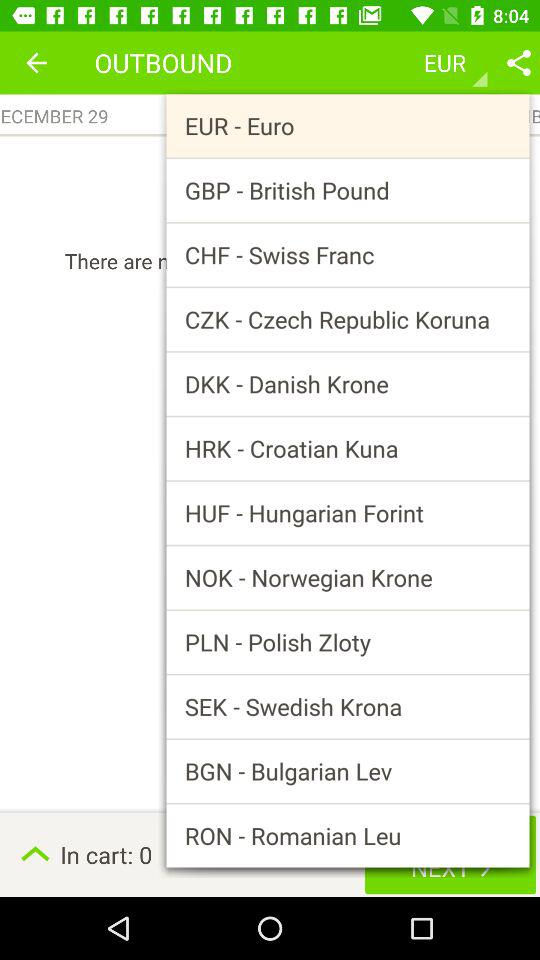What is the selected currency? The selected currency is the euro. 